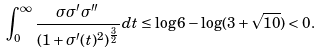<formula> <loc_0><loc_0><loc_500><loc_500>\int _ { 0 } ^ { \infty } \frac { \sigma \sigma ^ { \prime } \sigma ^ { \prime \prime } } { ( 1 + \sigma ^ { \prime } ( t ) ^ { 2 } ) ^ { \frac { 3 } { 2 } } } d t \leq \log 6 - \log ( 3 + \sqrt { 1 0 } ) < 0 .</formula> 